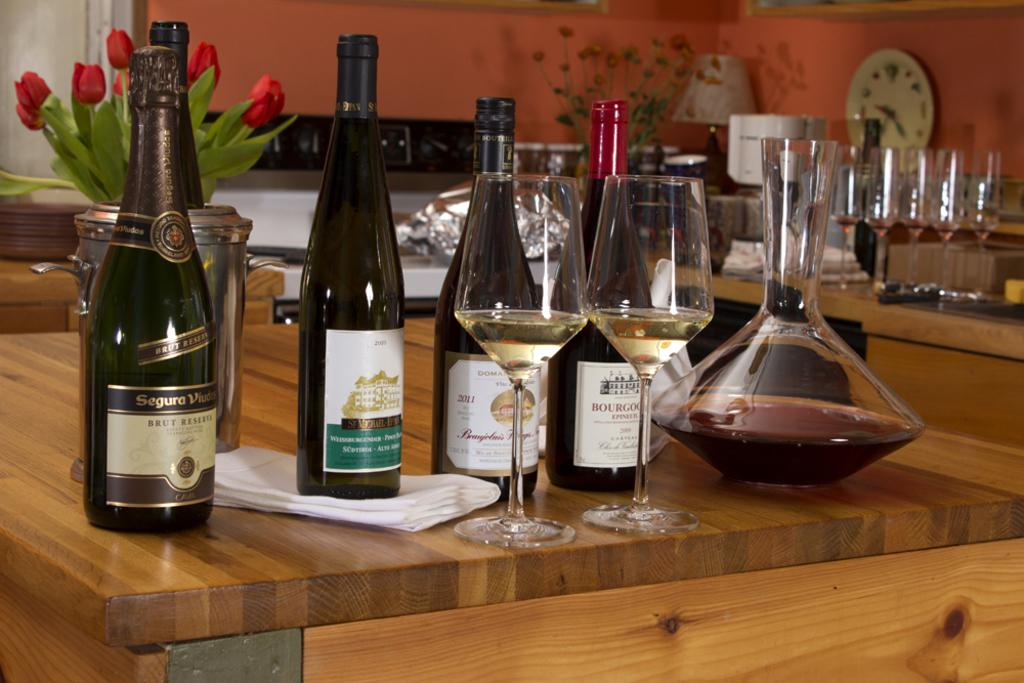What type of beverage containers are present in the image? There are wine bottles in the image. What features can be observed on the wine bottles? The wine bottles have labels and lids. What type of glassware is visible in the image? There are wine glasses in the image. What other objects can be seen on the table? There is a pot, a clock, a lamp, and plants on the table. What is covering the objects on the table? There is a cover in the image. What can be seen in the background of the image? There is a wall and a frame in the background of the image. What type of current is flowing through the coal in the image? There is no coal present in the image, and therefore no current can be observed. 